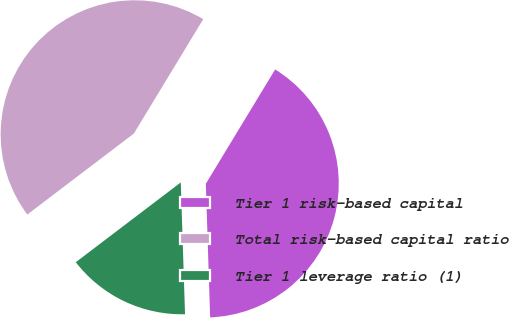Convert chart. <chart><loc_0><loc_0><loc_500><loc_500><pie_chart><fcel>Tier 1 risk-based capital<fcel>Total risk-based capital ratio<fcel>Tier 1 leverage ratio (1)<nl><fcel>40.81%<fcel>44.02%<fcel>15.17%<nl></chart> 